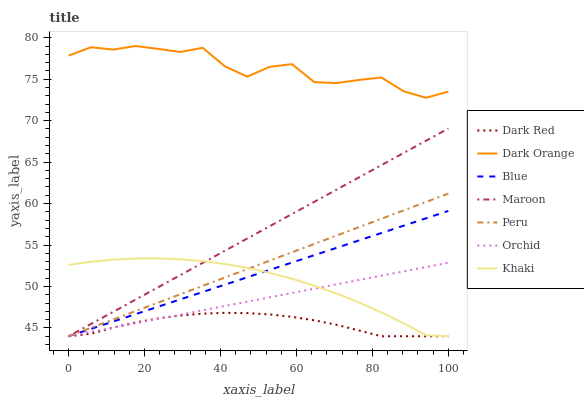Does Dark Red have the minimum area under the curve?
Answer yes or no. Yes. Does Dark Orange have the maximum area under the curve?
Answer yes or no. Yes. Does Khaki have the minimum area under the curve?
Answer yes or no. No. Does Khaki have the maximum area under the curve?
Answer yes or no. No. Is Peru the smoothest?
Answer yes or no. Yes. Is Dark Orange the roughest?
Answer yes or no. Yes. Is Khaki the smoothest?
Answer yes or no. No. Is Khaki the roughest?
Answer yes or no. No. Does Dark Orange have the lowest value?
Answer yes or no. No. Does Dark Orange have the highest value?
Answer yes or no. Yes. Does Khaki have the highest value?
Answer yes or no. No. Is Khaki less than Dark Orange?
Answer yes or no. Yes. Is Dark Orange greater than Khaki?
Answer yes or no. Yes. Does Khaki intersect Blue?
Answer yes or no. Yes. Is Khaki less than Blue?
Answer yes or no. No. Is Khaki greater than Blue?
Answer yes or no. No. Does Khaki intersect Dark Orange?
Answer yes or no. No. 